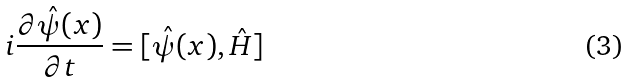Convert formula to latex. <formula><loc_0><loc_0><loc_500><loc_500>i \frac { \partial \hat { \psi } ( x ) } { \partial t } = [ \hat { \psi } ( x ) , \hat { H } ]</formula> 